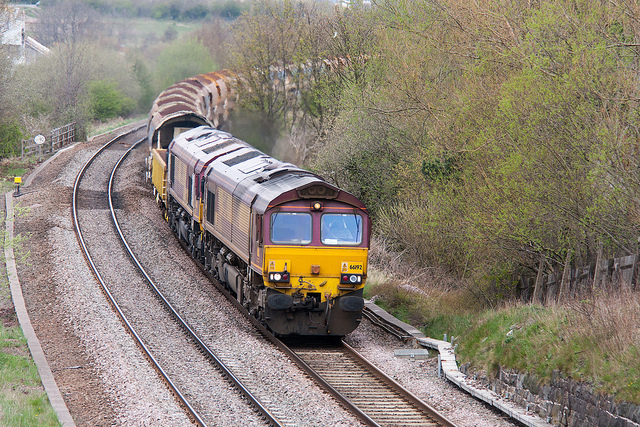Please identify all text content in this image. 66292 